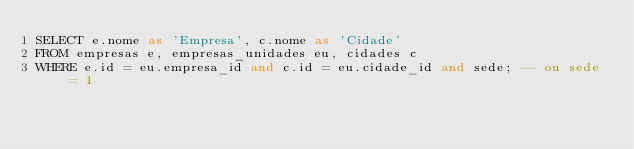Convert code to text. <code><loc_0><loc_0><loc_500><loc_500><_SQL_>SELECT e.nome as 'Empresa', c.nome as 'Cidade' 
FROM empresas e, empresas_unidades eu, cidades c
WHERE e.id = eu.empresa_id and c.id = eu.cidade_id and sede; -- ou sede = 1</code> 